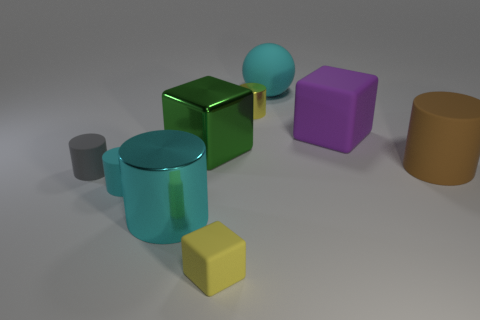Add 1 cyan metal things. How many objects exist? 10 Subtract all big brown cylinders. How many cylinders are left? 4 Subtract 3 cylinders. How many cylinders are left? 2 Subtract all yellow cubes. How many cyan cylinders are left? 2 Subtract 1 brown cylinders. How many objects are left? 8 Subtract all cylinders. How many objects are left? 4 Subtract all gray balls. Subtract all yellow cubes. How many balls are left? 1 Subtract all tiny gray matte cubes. Subtract all yellow rubber cubes. How many objects are left? 8 Add 6 tiny matte cylinders. How many tiny matte cylinders are left? 8 Add 3 cyan shiny cylinders. How many cyan shiny cylinders exist? 4 